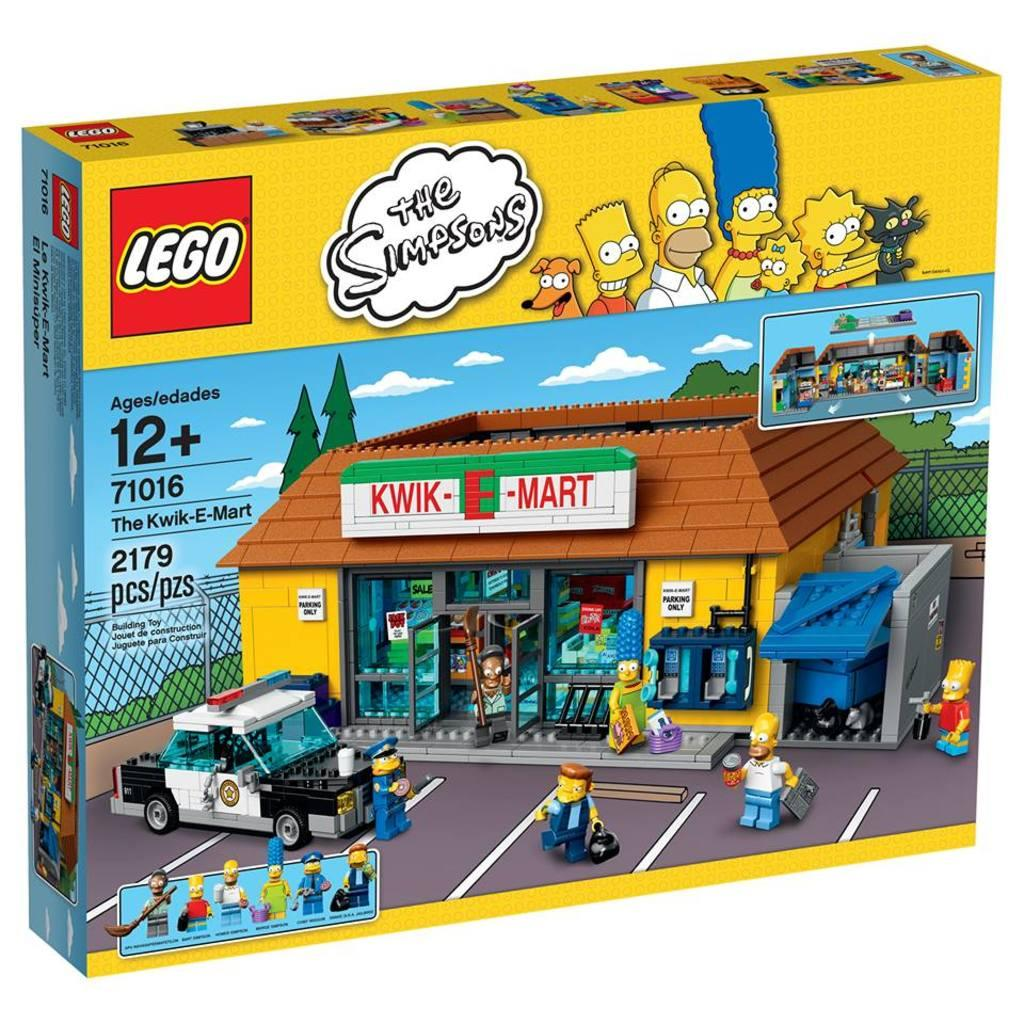What object is present in the image that is typically used for storing toys? There is a toy box in the image. What type of plane can be seen flying over the yard in the image? There is no plane or yard present in the image; it only features a toy box. 